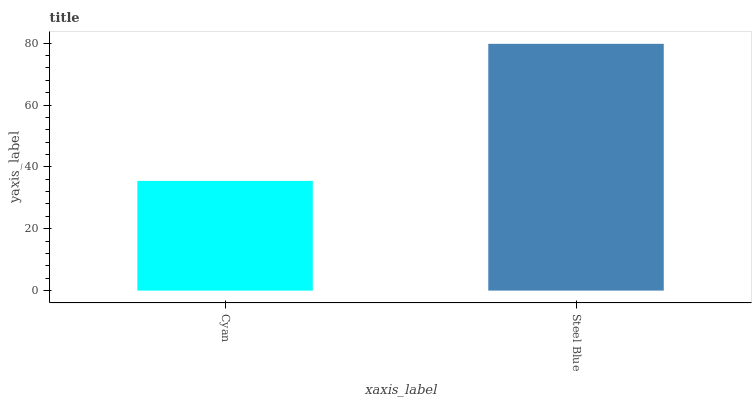Is Cyan the minimum?
Answer yes or no. Yes. Is Steel Blue the maximum?
Answer yes or no. Yes. Is Steel Blue the minimum?
Answer yes or no. No. Is Steel Blue greater than Cyan?
Answer yes or no. Yes. Is Cyan less than Steel Blue?
Answer yes or no. Yes. Is Cyan greater than Steel Blue?
Answer yes or no. No. Is Steel Blue less than Cyan?
Answer yes or no. No. Is Steel Blue the high median?
Answer yes or no. Yes. Is Cyan the low median?
Answer yes or no. Yes. Is Cyan the high median?
Answer yes or no. No. Is Steel Blue the low median?
Answer yes or no. No. 